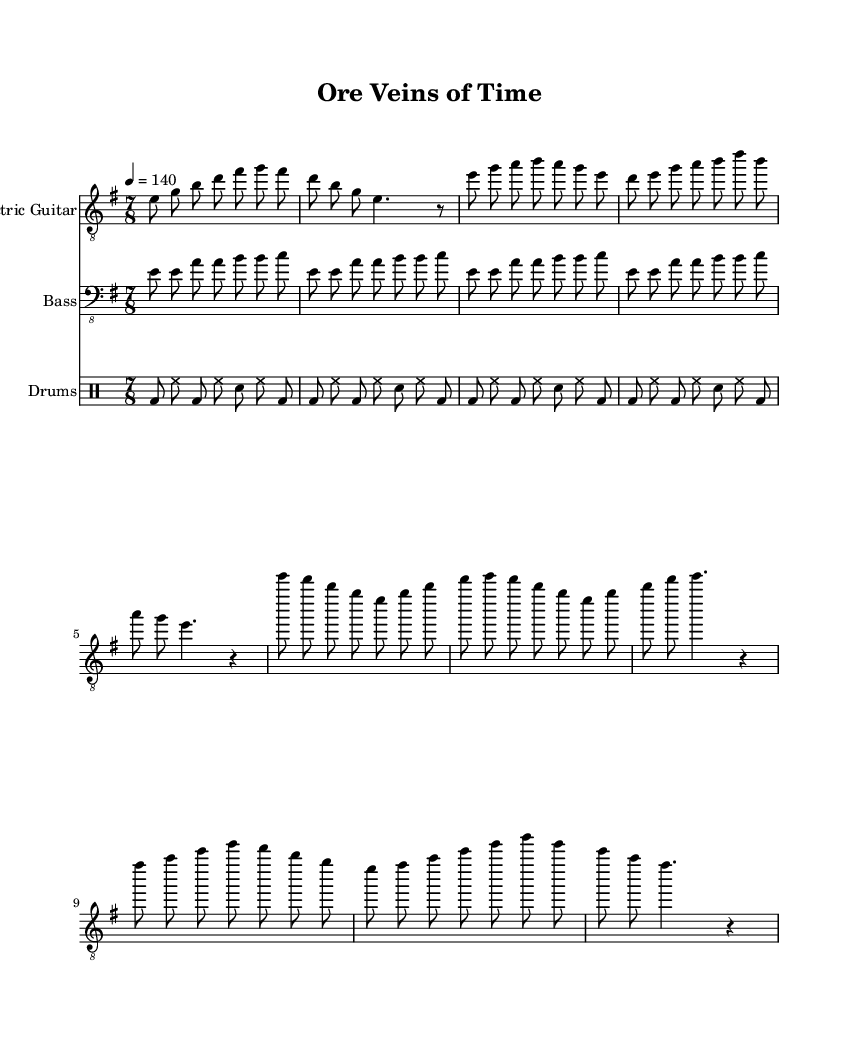what is the key signature of this music? The key signature is indicated at the beginning of the score, where it states E minor. E minor has one sharp, which is F#.
Answer: E minor what is the time signature of this piece? The time signature is shown at the beginning, indicated by 7/8. This means there are seven beats per measure, and the eighth note gets one beat.
Answer: 7/8 what is the tempo marking for this composition? The tempo marking is located at the start of the score, stating "4 = 140." This indicates the quarter note should be played at a speed of 140 beats per minute.
Answer: 140 how many measures are in the Intro? The Intro consists of one measure repeated along with another, totaling to 2 measures of music. The counting of measures is done by counting the vertical lines or bar lines separating the sections.
Answer: 2 what is the primary instrument shown in this score? The score has multiple instruments, but the main instrument is indicated as "Electric Guitar" at the top of the staff. This identifies it as the leading instrument in the composition.
Answer: Electric Guitar what type of drum pattern is used throughout the piece? The drum pattern shown follows a basic rock style, which is derived from the repeated sequence of bass drum and snare drum hits. This is common in metal music, providing a strong rhythmic foundation.
Answer: Basic rock pattern how many times does the bass guitar groove repeat in the Intro and verse? The bass guitar groove pattern is repeated four times in each section, as indicated by the repeat sign in the bass part. This shows the typical repetition structure seen in metal music for enhancing the groove.
Answer: 4 